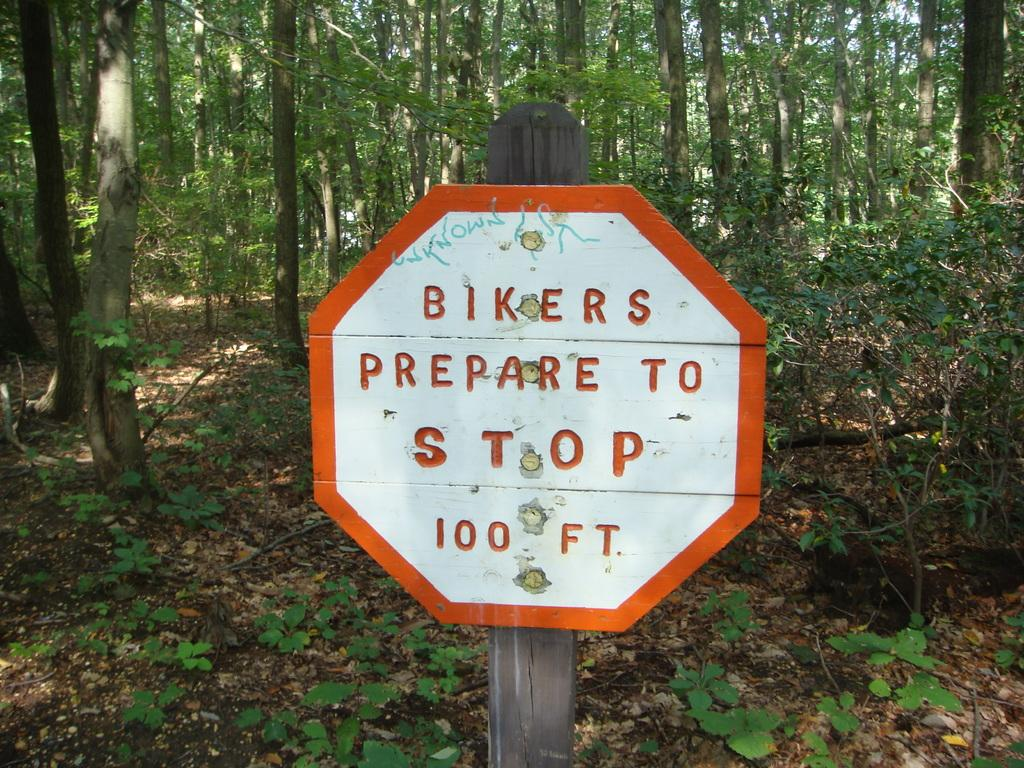What is located in the foreground of the picture? There are plants, leaves, and a board in the foreground of the picture. What type of vegetation is visible in the foreground? The plants and leaves in the foreground are visible. What can be seen in the center of the picture? There are trees in the center of the picture. What type of lock can be seen on the tray in the image? There is no tray or lock present in the image. Can you describe the curtain in the image? There is no curtain present in the image. 